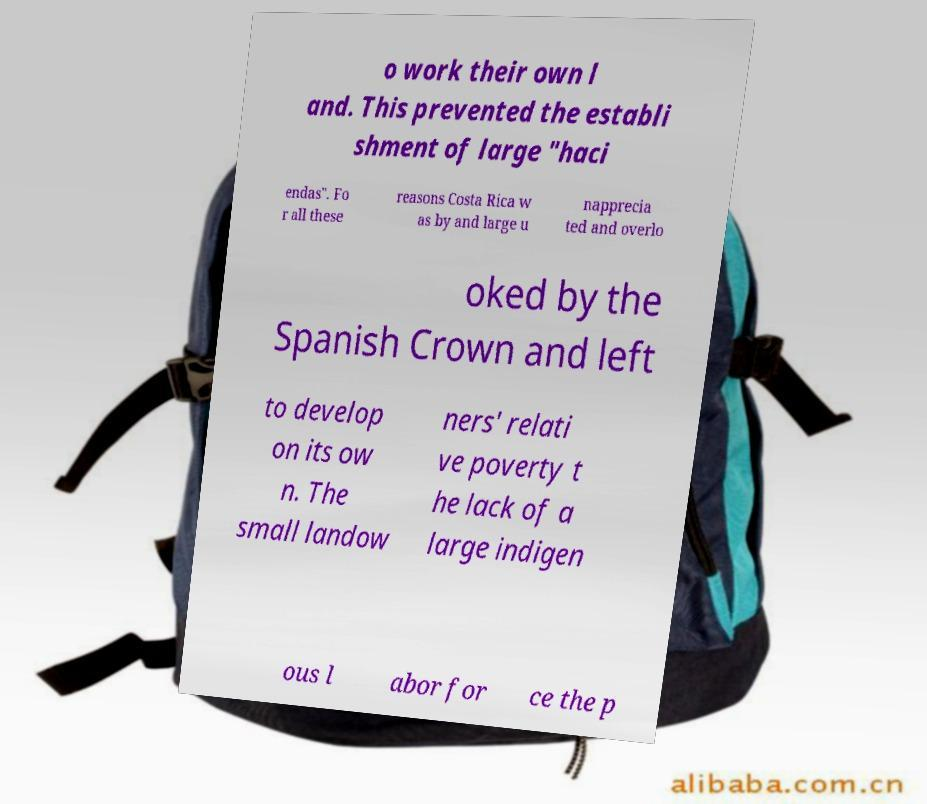Please read and relay the text visible in this image. What does it say? o work their own l and. This prevented the establi shment of large "haci endas". Fo r all these reasons Costa Rica w as by and large u napprecia ted and overlo oked by the Spanish Crown and left to develop on its ow n. The small landow ners' relati ve poverty t he lack of a large indigen ous l abor for ce the p 